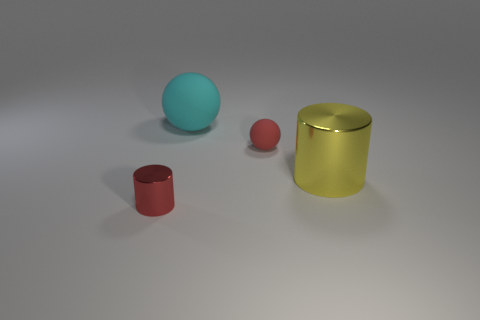Subtract all gray balls. Subtract all yellow cylinders. How many balls are left? 2 Subtract all purple cylinders. How many gray spheres are left? 0 Add 2 small objects. How many yellows exist? 0 Subtract all big blue matte spheres. Subtract all yellow metallic cylinders. How many objects are left? 3 Add 1 red cylinders. How many red cylinders are left? 2 Add 1 big things. How many big things exist? 3 Add 4 matte objects. How many objects exist? 8 Subtract all red balls. How many balls are left? 1 Subtract 0 yellow blocks. How many objects are left? 4 Subtract 1 spheres. How many spheres are left? 1 